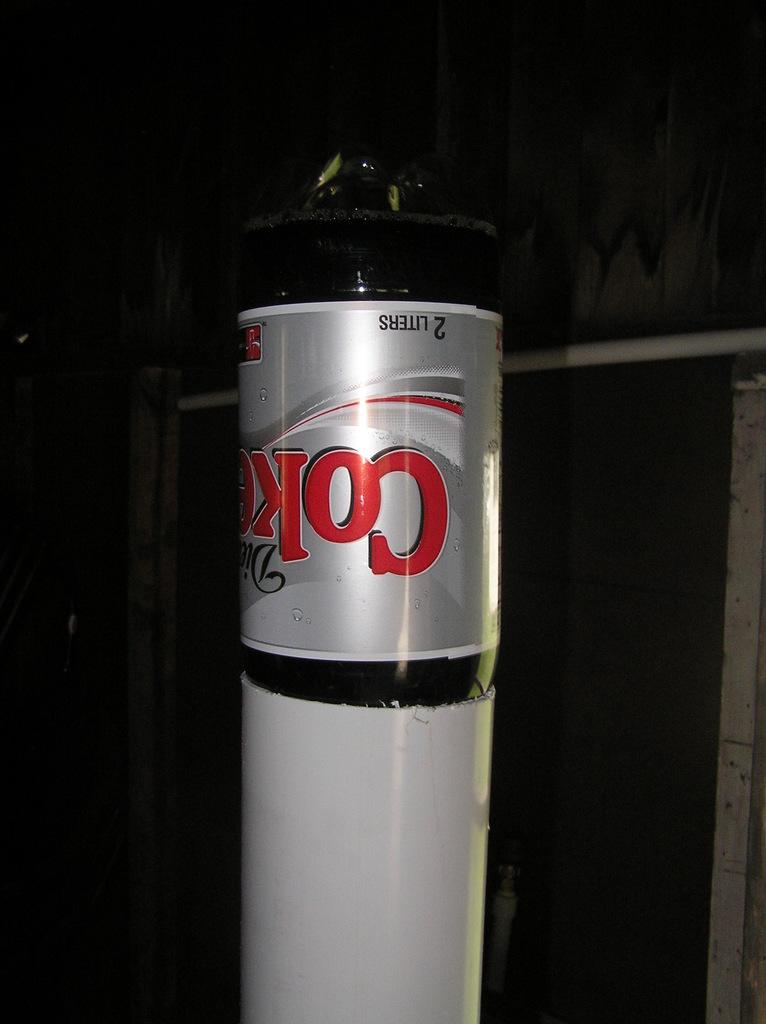How many liters is the bottle?
Make the answer very short. 2. 